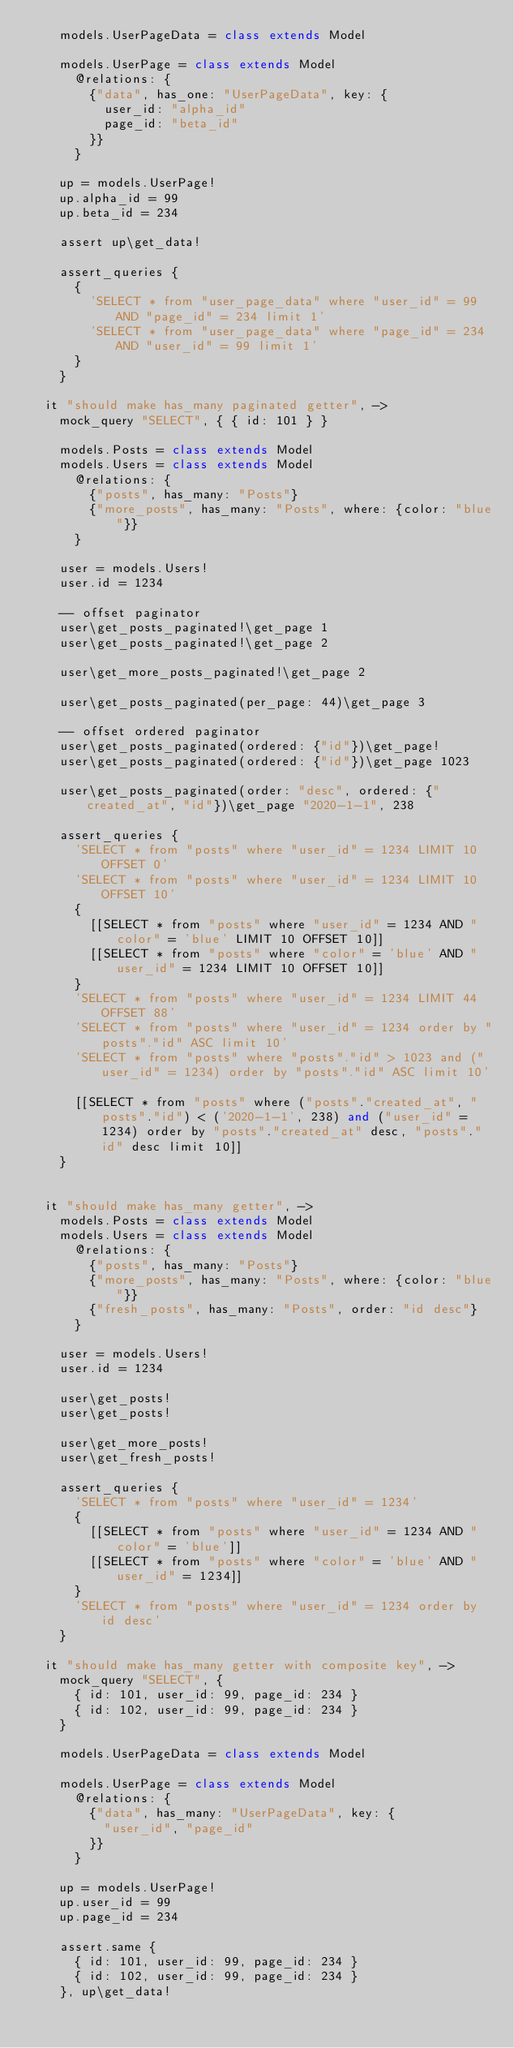<code> <loc_0><loc_0><loc_500><loc_500><_MoonScript_>    models.UserPageData = class extends Model

    models.UserPage = class extends Model
      @relations: {
        {"data", has_one: "UserPageData", key: {
          user_id: "alpha_id"
          page_id: "beta_id"
        }}
      }

    up = models.UserPage!
    up.alpha_id = 99
    up.beta_id = 234

    assert up\get_data!

    assert_queries {
      {
        'SELECT * from "user_page_data" where "user_id" = 99 AND "page_id" = 234 limit 1'
        'SELECT * from "user_page_data" where "page_id" = 234 AND "user_id" = 99 limit 1'
      }
    }

  it "should make has_many paginated getter", ->
    mock_query "SELECT", { { id: 101 } }

    models.Posts = class extends Model
    models.Users = class extends Model
      @relations: {
        {"posts", has_many: "Posts"}
        {"more_posts", has_many: "Posts", where: {color: "blue"}}
      }

    user = models.Users!
    user.id = 1234

    -- offset paginator
    user\get_posts_paginated!\get_page 1
    user\get_posts_paginated!\get_page 2

    user\get_more_posts_paginated!\get_page 2

    user\get_posts_paginated(per_page: 44)\get_page 3

    -- offset ordered paginator
    user\get_posts_paginated(ordered: {"id"})\get_page!
    user\get_posts_paginated(ordered: {"id"})\get_page 1023

    user\get_posts_paginated(order: "desc", ordered: {"created_at", "id"})\get_page "2020-1-1", 238

    assert_queries {
      'SELECT * from "posts" where "user_id" = 1234 LIMIT 10 OFFSET 0'
      'SELECT * from "posts" where "user_id" = 1234 LIMIT 10 OFFSET 10'
      {
        [[SELECT * from "posts" where "user_id" = 1234 AND "color" = 'blue' LIMIT 10 OFFSET 10]]
        [[SELECT * from "posts" where "color" = 'blue' AND "user_id" = 1234 LIMIT 10 OFFSET 10]]
      }
      'SELECT * from "posts" where "user_id" = 1234 LIMIT 44 OFFSET 88'
      'SELECT * from "posts" where "user_id" = 1234 order by "posts"."id" ASC limit 10'
      'SELECT * from "posts" where "posts"."id" > 1023 and ("user_id" = 1234) order by "posts"."id" ASC limit 10'

      [[SELECT * from "posts" where ("posts"."created_at", "posts"."id") < ('2020-1-1', 238) and ("user_id" = 1234) order by "posts"."created_at" desc, "posts"."id" desc limit 10]]
    }


  it "should make has_many getter", ->
    models.Posts = class extends Model
    models.Users = class extends Model
      @relations: {
        {"posts", has_many: "Posts"}
        {"more_posts", has_many: "Posts", where: {color: "blue"}}
        {"fresh_posts", has_many: "Posts", order: "id desc"}
      }

    user = models.Users!
    user.id = 1234

    user\get_posts!
    user\get_posts!

    user\get_more_posts!
    user\get_fresh_posts!

    assert_queries {
      'SELECT * from "posts" where "user_id" = 1234'
      {
        [[SELECT * from "posts" where "user_id" = 1234 AND "color" = 'blue']]
        [[SELECT * from "posts" where "color" = 'blue' AND "user_id" = 1234]]
      }
      'SELECT * from "posts" where "user_id" = 1234 order by id desc'
    }

  it "should make has_many getter with composite key", ->
    mock_query "SELECT", {
      { id: 101, user_id: 99, page_id: 234 }
      { id: 102, user_id: 99, page_id: 234 }
    }

    models.UserPageData = class extends Model

    models.UserPage = class extends Model
      @relations: {
        {"data", has_many: "UserPageData", key: {
          "user_id", "page_id"
        }}
      }

    up = models.UserPage!
    up.user_id = 99
    up.page_id = 234

    assert.same {
      { id: 101, user_id: 99, page_id: 234 }
      { id: 102, user_id: 99, page_id: 234 }
    }, up\get_data!
</code> 